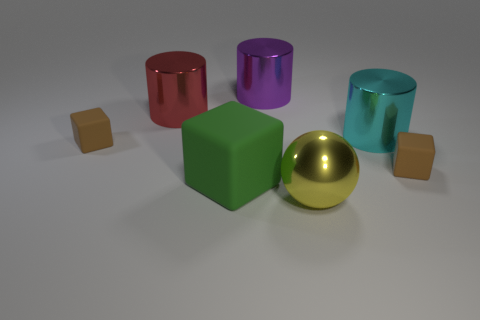Add 1 brown cubes. How many objects exist? 8 Subtract all cyan spheres. Subtract all brown blocks. How many spheres are left? 1 Subtract all blocks. How many objects are left? 4 Subtract 0 brown cylinders. How many objects are left? 7 Subtract all rubber cubes. Subtract all purple metallic objects. How many objects are left? 3 Add 1 green matte objects. How many green matte objects are left? 2 Add 7 big matte objects. How many big matte objects exist? 8 